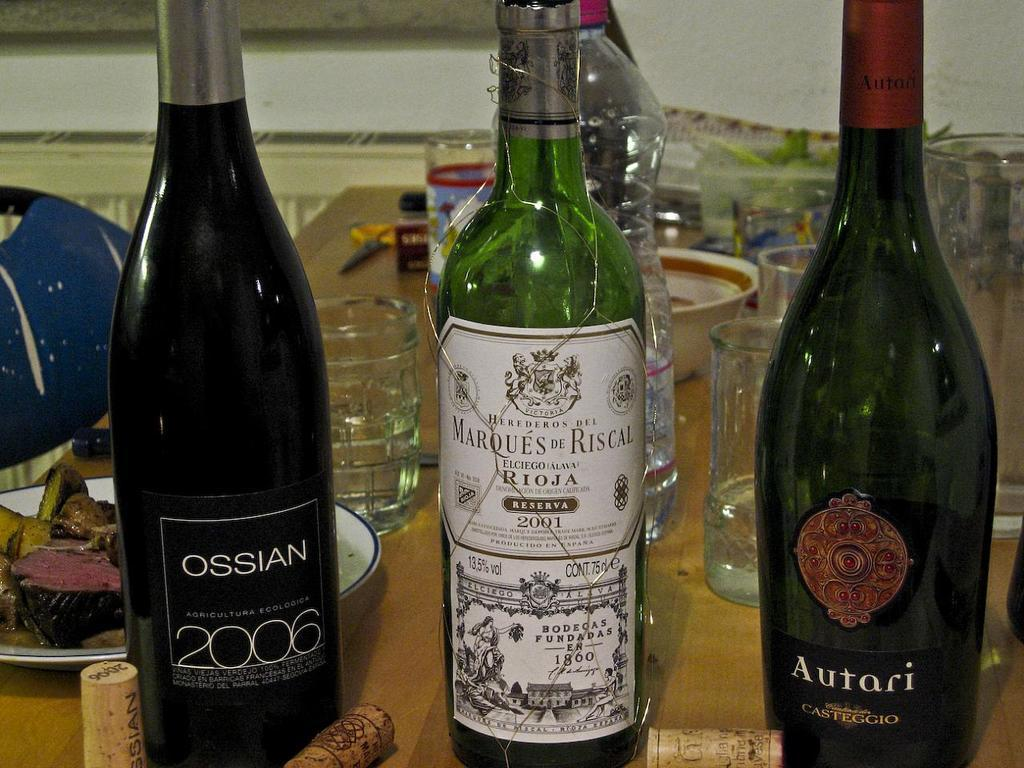<image>
Relay a brief, clear account of the picture shown. several bottles of liquor including Ossian and Autari 